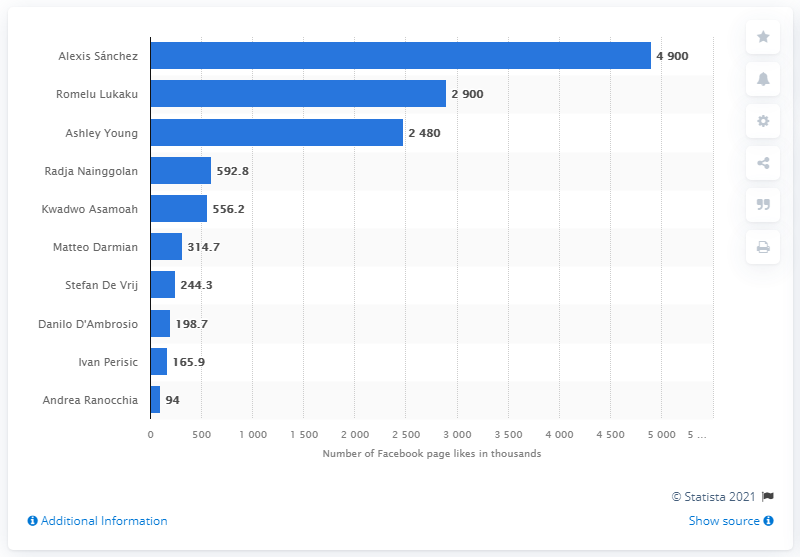Draw attention to some important aspects in this diagram. Romelu Lukaku was the most popular player on Facebook as of October 2020. 